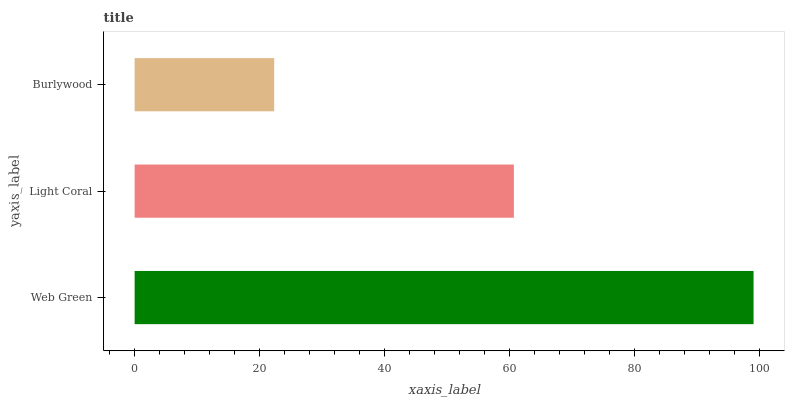Is Burlywood the minimum?
Answer yes or no. Yes. Is Web Green the maximum?
Answer yes or no. Yes. Is Light Coral the minimum?
Answer yes or no. No. Is Light Coral the maximum?
Answer yes or no. No. Is Web Green greater than Light Coral?
Answer yes or no. Yes. Is Light Coral less than Web Green?
Answer yes or no. Yes. Is Light Coral greater than Web Green?
Answer yes or no. No. Is Web Green less than Light Coral?
Answer yes or no. No. Is Light Coral the high median?
Answer yes or no. Yes. Is Light Coral the low median?
Answer yes or no. Yes. Is Burlywood the high median?
Answer yes or no. No. Is Burlywood the low median?
Answer yes or no. No. 